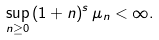Convert formula to latex. <formula><loc_0><loc_0><loc_500><loc_500>\sup _ { n \geq 0 } \, ( 1 + n ) ^ { s } \, \mu _ { n } < \infty .</formula> 